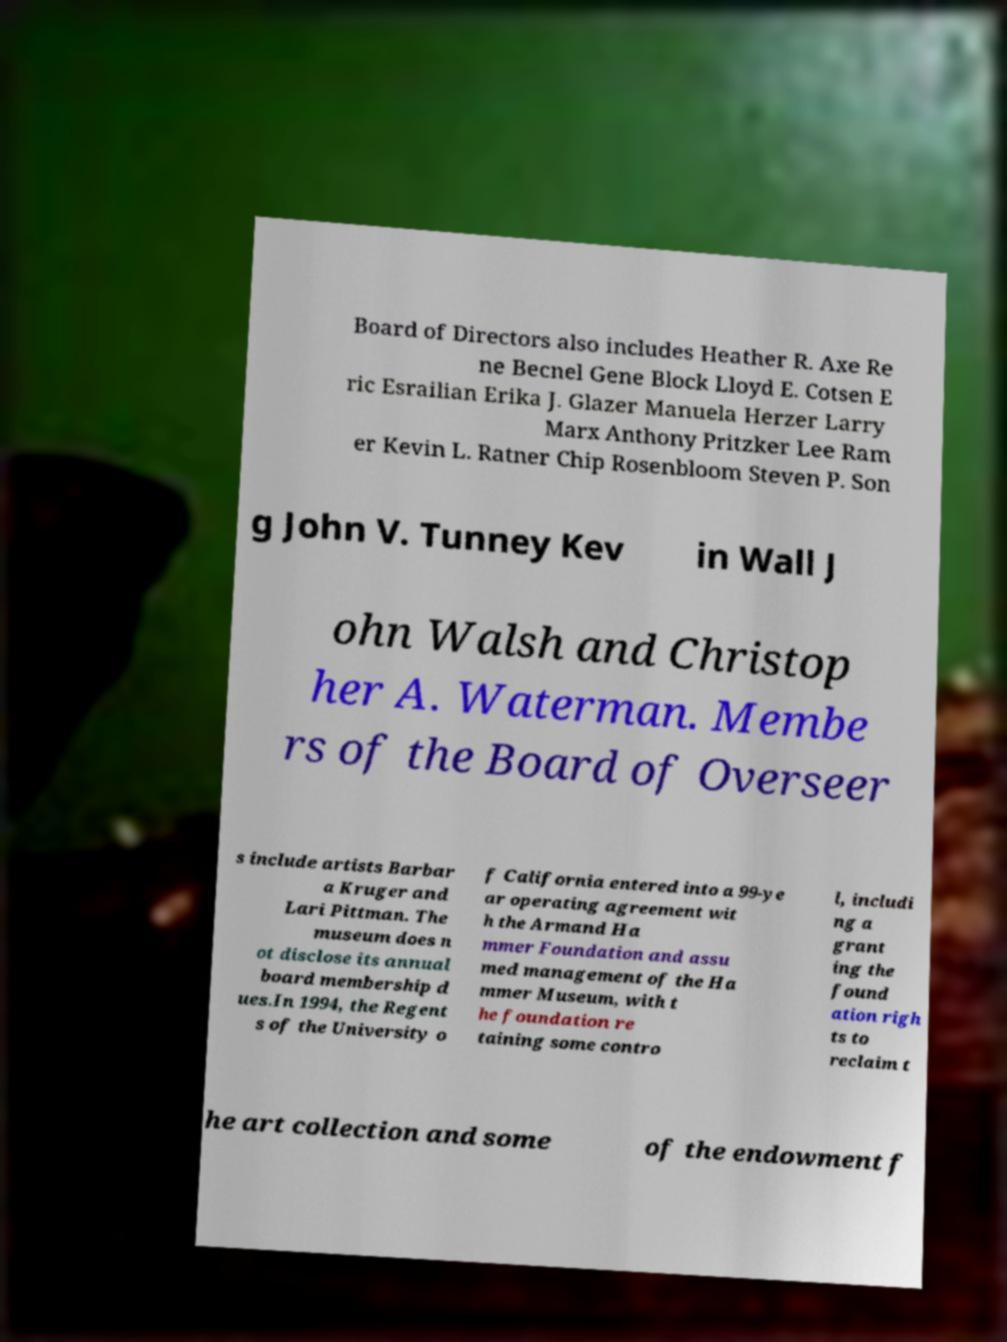Please read and relay the text visible in this image. What does it say? Board of Directors also includes Heather R. Axe Re ne Becnel Gene Block Lloyd E. Cotsen E ric Esrailian Erika J. Glazer Manuela Herzer Larry Marx Anthony Pritzker Lee Ram er Kevin L. Ratner Chip Rosenbloom Steven P. Son g John V. Tunney Kev in Wall J ohn Walsh and Christop her A. Waterman. Membe rs of the Board of Overseer s include artists Barbar a Kruger and Lari Pittman. The museum does n ot disclose its annual board membership d ues.In 1994, the Regent s of the University o f California entered into a 99-ye ar operating agreement wit h the Armand Ha mmer Foundation and assu med management of the Ha mmer Museum, with t he foundation re taining some contro l, includi ng a grant ing the found ation righ ts to reclaim t he art collection and some of the endowment f 